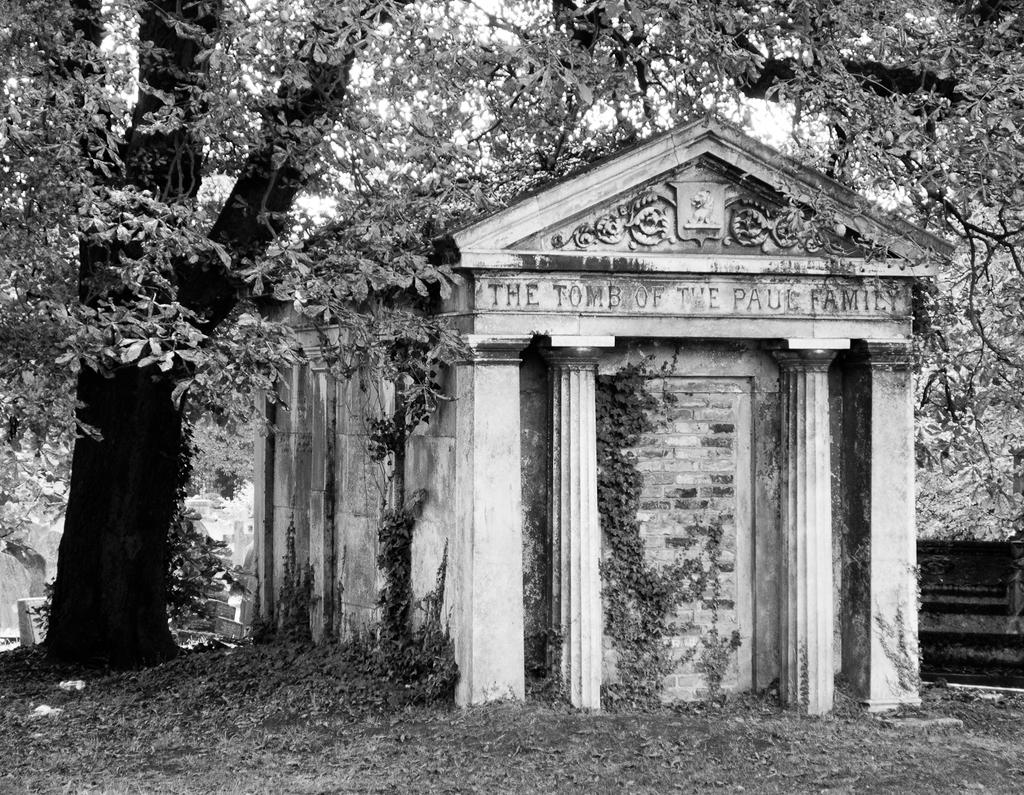What is the color scheme of the image? The image is black and white. What is the main subject in the image? There is a tombstone in the image. What can be seen in the background of the image? There are trees in the background of the image. What type of furniture is present in the image? There is no furniture present in the image; it features a tombstone and trees in the background. What relation does the person have with the individual whose tombstone is in the image? The image does not provide any information about the person viewing the tombstone or their relation to the deceased. 